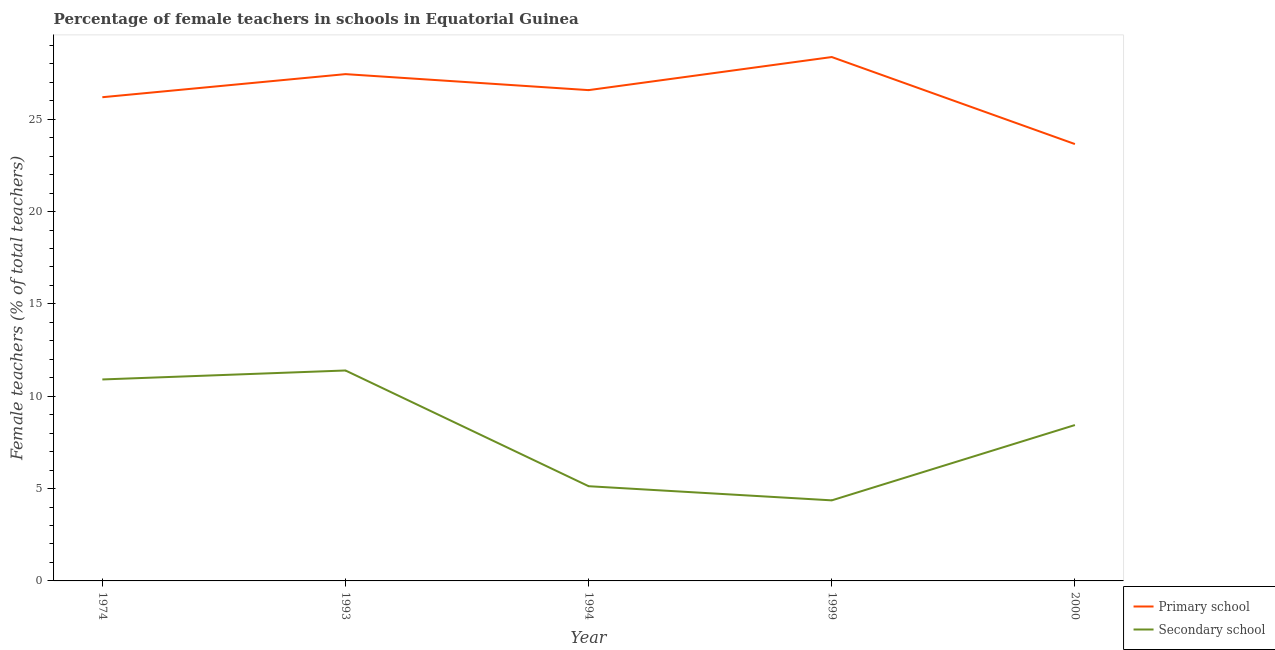Does the line corresponding to percentage of female teachers in secondary schools intersect with the line corresponding to percentage of female teachers in primary schools?
Your answer should be compact. No. Is the number of lines equal to the number of legend labels?
Your answer should be compact. Yes. What is the percentage of female teachers in secondary schools in 2000?
Your answer should be very brief. 8.44. Across all years, what is the maximum percentage of female teachers in primary schools?
Your answer should be compact. 28.37. Across all years, what is the minimum percentage of female teachers in primary schools?
Offer a terse response. 23.65. In which year was the percentage of female teachers in secondary schools minimum?
Provide a short and direct response. 1999. What is the total percentage of female teachers in primary schools in the graph?
Give a very brief answer. 132.23. What is the difference between the percentage of female teachers in primary schools in 1974 and that in 1999?
Offer a terse response. -2.18. What is the difference between the percentage of female teachers in secondary schools in 1974 and the percentage of female teachers in primary schools in 1993?
Your answer should be compact. -16.53. What is the average percentage of female teachers in secondary schools per year?
Your answer should be compact. 8.05. In the year 2000, what is the difference between the percentage of female teachers in primary schools and percentage of female teachers in secondary schools?
Keep it short and to the point. 15.21. In how many years, is the percentage of female teachers in secondary schools greater than 26 %?
Provide a succinct answer. 0. What is the ratio of the percentage of female teachers in primary schools in 1974 to that in 1994?
Your answer should be very brief. 0.99. What is the difference between the highest and the second highest percentage of female teachers in secondary schools?
Make the answer very short. 0.49. What is the difference between the highest and the lowest percentage of female teachers in secondary schools?
Make the answer very short. 7.03. Is the sum of the percentage of female teachers in primary schools in 1994 and 2000 greater than the maximum percentage of female teachers in secondary schools across all years?
Offer a terse response. Yes. Does the percentage of female teachers in primary schools monotonically increase over the years?
Your response must be concise. No. Is the percentage of female teachers in primary schools strictly less than the percentage of female teachers in secondary schools over the years?
Give a very brief answer. No. How many lines are there?
Keep it short and to the point. 2. What is the difference between two consecutive major ticks on the Y-axis?
Your answer should be compact. 5. How many legend labels are there?
Your response must be concise. 2. How are the legend labels stacked?
Provide a succinct answer. Vertical. What is the title of the graph?
Offer a terse response. Percentage of female teachers in schools in Equatorial Guinea. What is the label or title of the X-axis?
Ensure brevity in your answer.  Year. What is the label or title of the Y-axis?
Your response must be concise. Female teachers (% of total teachers). What is the Female teachers (% of total teachers) of Primary school in 1974?
Provide a succinct answer. 26.19. What is the Female teachers (% of total teachers) in Secondary school in 1974?
Ensure brevity in your answer.  10.91. What is the Female teachers (% of total teachers) of Primary school in 1993?
Your answer should be compact. 27.44. What is the Female teachers (% of total teachers) of Secondary school in 1993?
Offer a terse response. 11.39. What is the Female teachers (% of total teachers) of Primary school in 1994?
Offer a terse response. 26.57. What is the Female teachers (% of total teachers) of Secondary school in 1994?
Offer a very short reply. 5.13. What is the Female teachers (% of total teachers) in Primary school in 1999?
Your answer should be compact. 28.37. What is the Female teachers (% of total teachers) in Secondary school in 1999?
Your answer should be compact. 4.36. What is the Female teachers (% of total teachers) in Primary school in 2000?
Give a very brief answer. 23.65. What is the Female teachers (% of total teachers) of Secondary school in 2000?
Make the answer very short. 8.44. Across all years, what is the maximum Female teachers (% of total teachers) of Primary school?
Your answer should be compact. 28.37. Across all years, what is the maximum Female teachers (% of total teachers) in Secondary school?
Offer a terse response. 11.39. Across all years, what is the minimum Female teachers (% of total teachers) in Primary school?
Your response must be concise. 23.65. Across all years, what is the minimum Female teachers (% of total teachers) of Secondary school?
Offer a terse response. 4.36. What is the total Female teachers (% of total teachers) in Primary school in the graph?
Your answer should be compact. 132.23. What is the total Female teachers (% of total teachers) in Secondary school in the graph?
Offer a very short reply. 40.23. What is the difference between the Female teachers (% of total teachers) in Primary school in 1974 and that in 1993?
Ensure brevity in your answer.  -1.25. What is the difference between the Female teachers (% of total teachers) in Secondary school in 1974 and that in 1993?
Your answer should be compact. -0.49. What is the difference between the Female teachers (% of total teachers) in Primary school in 1974 and that in 1994?
Keep it short and to the point. -0.38. What is the difference between the Female teachers (% of total teachers) in Secondary school in 1974 and that in 1994?
Ensure brevity in your answer.  5.78. What is the difference between the Female teachers (% of total teachers) in Primary school in 1974 and that in 1999?
Make the answer very short. -2.18. What is the difference between the Female teachers (% of total teachers) of Secondary school in 1974 and that in 1999?
Offer a terse response. 6.55. What is the difference between the Female teachers (% of total teachers) in Primary school in 1974 and that in 2000?
Make the answer very short. 2.54. What is the difference between the Female teachers (% of total teachers) in Secondary school in 1974 and that in 2000?
Your answer should be very brief. 2.47. What is the difference between the Female teachers (% of total teachers) of Primary school in 1993 and that in 1994?
Give a very brief answer. 0.87. What is the difference between the Female teachers (% of total teachers) of Secondary school in 1993 and that in 1994?
Offer a terse response. 6.27. What is the difference between the Female teachers (% of total teachers) of Primary school in 1993 and that in 1999?
Provide a succinct answer. -0.93. What is the difference between the Female teachers (% of total teachers) in Secondary school in 1993 and that in 1999?
Your response must be concise. 7.03. What is the difference between the Female teachers (% of total teachers) in Primary school in 1993 and that in 2000?
Provide a short and direct response. 3.79. What is the difference between the Female teachers (% of total teachers) of Secondary school in 1993 and that in 2000?
Give a very brief answer. 2.95. What is the difference between the Female teachers (% of total teachers) of Primary school in 1994 and that in 1999?
Your answer should be compact. -1.79. What is the difference between the Female teachers (% of total teachers) in Secondary school in 1994 and that in 1999?
Your answer should be very brief. 0.77. What is the difference between the Female teachers (% of total teachers) in Primary school in 1994 and that in 2000?
Offer a terse response. 2.92. What is the difference between the Female teachers (% of total teachers) of Secondary school in 1994 and that in 2000?
Your response must be concise. -3.31. What is the difference between the Female teachers (% of total teachers) in Primary school in 1999 and that in 2000?
Your answer should be very brief. 4.71. What is the difference between the Female teachers (% of total teachers) of Secondary school in 1999 and that in 2000?
Offer a very short reply. -4.08. What is the difference between the Female teachers (% of total teachers) of Primary school in 1974 and the Female teachers (% of total teachers) of Secondary school in 1993?
Your response must be concise. 14.8. What is the difference between the Female teachers (% of total teachers) of Primary school in 1974 and the Female teachers (% of total teachers) of Secondary school in 1994?
Provide a short and direct response. 21.06. What is the difference between the Female teachers (% of total teachers) of Primary school in 1974 and the Female teachers (% of total teachers) of Secondary school in 1999?
Your answer should be compact. 21.83. What is the difference between the Female teachers (% of total teachers) of Primary school in 1974 and the Female teachers (% of total teachers) of Secondary school in 2000?
Give a very brief answer. 17.75. What is the difference between the Female teachers (% of total teachers) in Primary school in 1993 and the Female teachers (% of total teachers) in Secondary school in 1994?
Keep it short and to the point. 22.31. What is the difference between the Female teachers (% of total teachers) of Primary school in 1993 and the Female teachers (% of total teachers) of Secondary school in 1999?
Make the answer very short. 23.08. What is the difference between the Female teachers (% of total teachers) in Primary school in 1993 and the Female teachers (% of total teachers) in Secondary school in 2000?
Offer a terse response. 19. What is the difference between the Female teachers (% of total teachers) in Primary school in 1994 and the Female teachers (% of total teachers) in Secondary school in 1999?
Give a very brief answer. 22.21. What is the difference between the Female teachers (% of total teachers) of Primary school in 1994 and the Female teachers (% of total teachers) of Secondary school in 2000?
Make the answer very short. 18.13. What is the difference between the Female teachers (% of total teachers) in Primary school in 1999 and the Female teachers (% of total teachers) in Secondary school in 2000?
Your answer should be very brief. 19.93. What is the average Female teachers (% of total teachers) of Primary school per year?
Offer a terse response. 26.45. What is the average Female teachers (% of total teachers) of Secondary school per year?
Give a very brief answer. 8.05. In the year 1974, what is the difference between the Female teachers (% of total teachers) in Primary school and Female teachers (% of total teachers) in Secondary school?
Give a very brief answer. 15.28. In the year 1993, what is the difference between the Female teachers (% of total teachers) of Primary school and Female teachers (% of total teachers) of Secondary school?
Offer a very short reply. 16.05. In the year 1994, what is the difference between the Female teachers (% of total teachers) in Primary school and Female teachers (% of total teachers) in Secondary school?
Keep it short and to the point. 21.45. In the year 1999, what is the difference between the Female teachers (% of total teachers) in Primary school and Female teachers (% of total teachers) in Secondary school?
Your answer should be very brief. 24. In the year 2000, what is the difference between the Female teachers (% of total teachers) of Primary school and Female teachers (% of total teachers) of Secondary school?
Offer a terse response. 15.21. What is the ratio of the Female teachers (% of total teachers) in Primary school in 1974 to that in 1993?
Provide a short and direct response. 0.95. What is the ratio of the Female teachers (% of total teachers) of Secondary school in 1974 to that in 1993?
Your answer should be very brief. 0.96. What is the ratio of the Female teachers (% of total teachers) in Primary school in 1974 to that in 1994?
Offer a very short reply. 0.99. What is the ratio of the Female teachers (% of total teachers) of Secondary school in 1974 to that in 1994?
Your answer should be very brief. 2.13. What is the ratio of the Female teachers (% of total teachers) of Primary school in 1974 to that in 1999?
Make the answer very short. 0.92. What is the ratio of the Female teachers (% of total teachers) of Secondary school in 1974 to that in 1999?
Provide a short and direct response. 2.5. What is the ratio of the Female teachers (% of total teachers) in Primary school in 1974 to that in 2000?
Your response must be concise. 1.11. What is the ratio of the Female teachers (% of total teachers) of Secondary school in 1974 to that in 2000?
Your answer should be very brief. 1.29. What is the ratio of the Female teachers (% of total teachers) in Primary school in 1993 to that in 1994?
Provide a short and direct response. 1.03. What is the ratio of the Female teachers (% of total teachers) of Secondary school in 1993 to that in 1994?
Give a very brief answer. 2.22. What is the ratio of the Female teachers (% of total teachers) in Primary school in 1993 to that in 1999?
Keep it short and to the point. 0.97. What is the ratio of the Female teachers (% of total teachers) in Secondary school in 1993 to that in 1999?
Your response must be concise. 2.61. What is the ratio of the Female teachers (% of total teachers) of Primary school in 1993 to that in 2000?
Keep it short and to the point. 1.16. What is the ratio of the Female teachers (% of total teachers) in Secondary school in 1993 to that in 2000?
Your response must be concise. 1.35. What is the ratio of the Female teachers (% of total teachers) of Primary school in 1994 to that in 1999?
Give a very brief answer. 0.94. What is the ratio of the Female teachers (% of total teachers) in Secondary school in 1994 to that in 1999?
Make the answer very short. 1.18. What is the ratio of the Female teachers (% of total teachers) of Primary school in 1994 to that in 2000?
Your response must be concise. 1.12. What is the ratio of the Female teachers (% of total teachers) of Secondary school in 1994 to that in 2000?
Offer a very short reply. 0.61. What is the ratio of the Female teachers (% of total teachers) of Primary school in 1999 to that in 2000?
Your answer should be compact. 1.2. What is the ratio of the Female teachers (% of total teachers) of Secondary school in 1999 to that in 2000?
Make the answer very short. 0.52. What is the difference between the highest and the second highest Female teachers (% of total teachers) in Primary school?
Your answer should be very brief. 0.93. What is the difference between the highest and the second highest Female teachers (% of total teachers) in Secondary school?
Provide a short and direct response. 0.49. What is the difference between the highest and the lowest Female teachers (% of total teachers) in Primary school?
Ensure brevity in your answer.  4.71. What is the difference between the highest and the lowest Female teachers (% of total teachers) in Secondary school?
Your response must be concise. 7.03. 